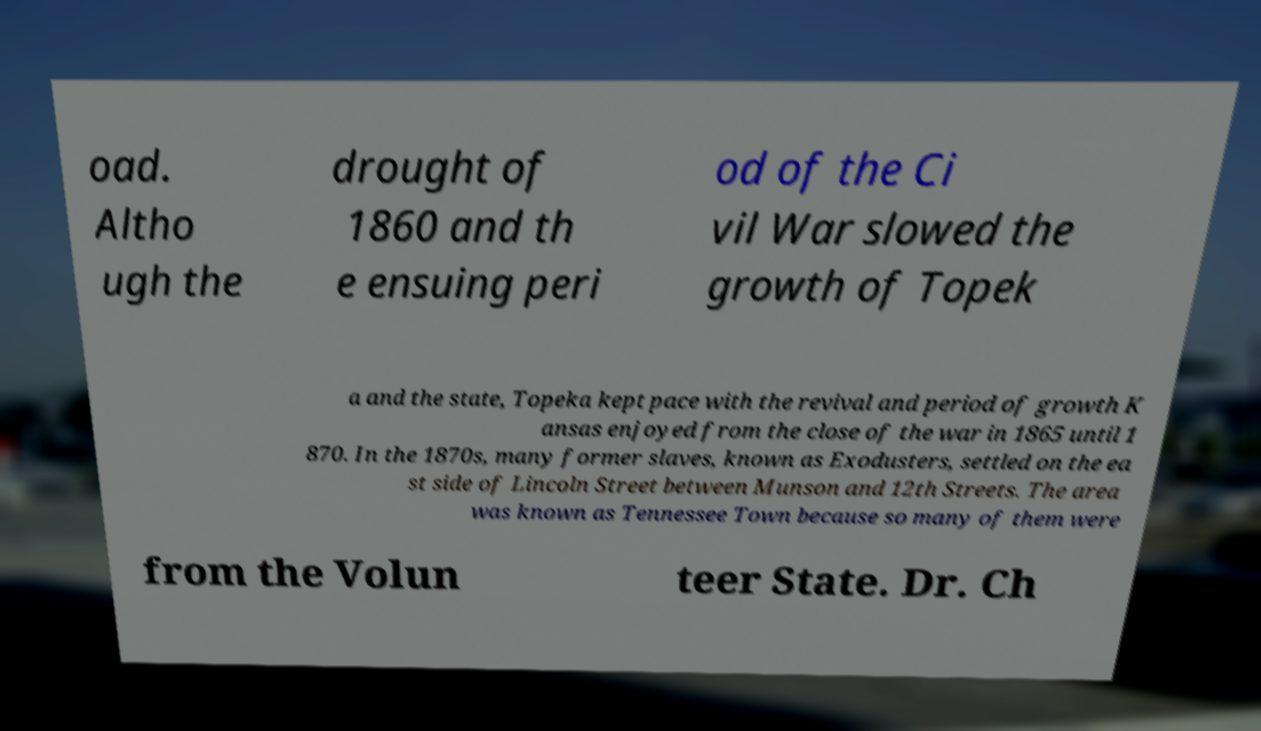Could you extract and type out the text from this image? oad. Altho ugh the drought of 1860 and th e ensuing peri od of the Ci vil War slowed the growth of Topek a and the state, Topeka kept pace with the revival and period of growth K ansas enjoyed from the close of the war in 1865 until 1 870. In the 1870s, many former slaves, known as Exodusters, settled on the ea st side of Lincoln Street between Munson and 12th Streets. The area was known as Tennessee Town because so many of them were from the Volun teer State. Dr. Ch 